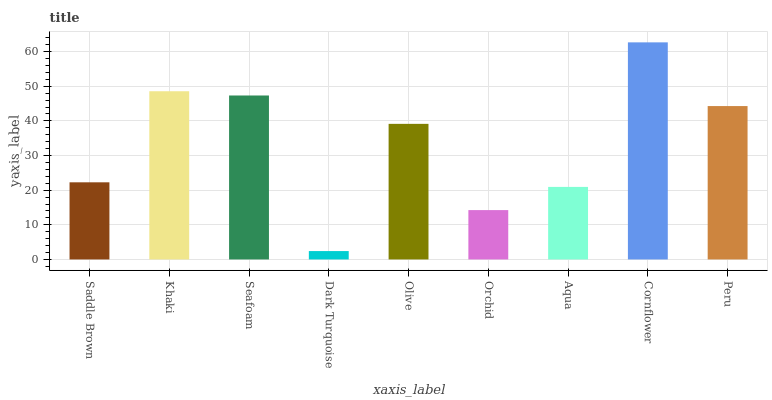Is Dark Turquoise the minimum?
Answer yes or no. Yes. Is Cornflower the maximum?
Answer yes or no. Yes. Is Khaki the minimum?
Answer yes or no. No. Is Khaki the maximum?
Answer yes or no. No. Is Khaki greater than Saddle Brown?
Answer yes or no. Yes. Is Saddle Brown less than Khaki?
Answer yes or no. Yes. Is Saddle Brown greater than Khaki?
Answer yes or no. No. Is Khaki less than Saddle Brown?
Answer yes or no. No. Is Olive the high median?
Answer yes or no. Yes. Is Olive the low median?
Answer yes or no. Yes. Is Seafoam the high median?
Answer yes or no. No. Is Khaki the low median?
Answer yes or no. No. 